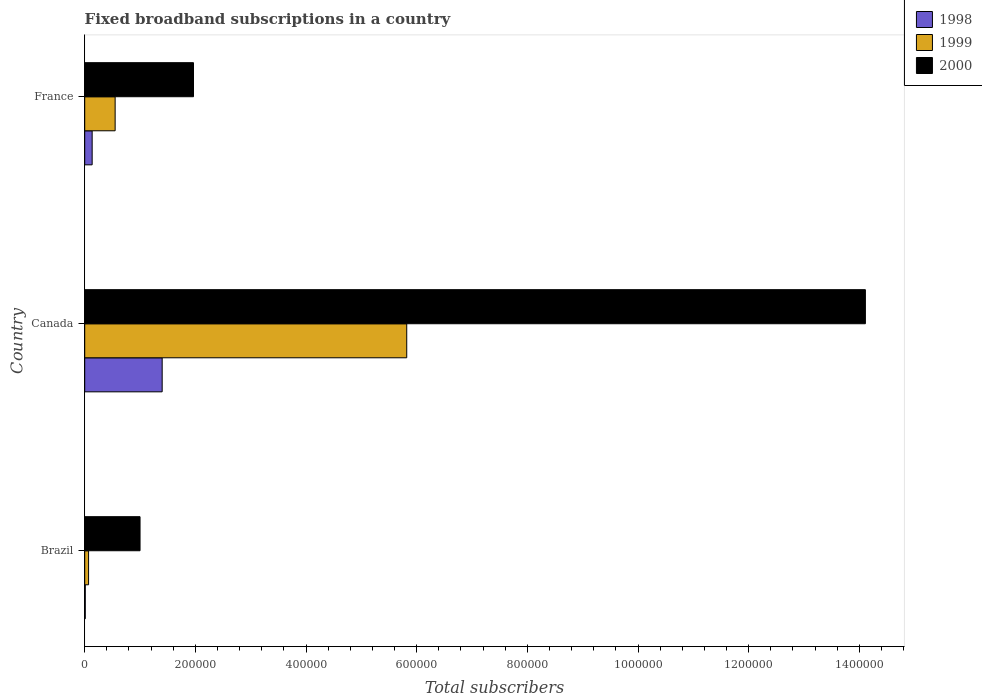How many groups of bars are there?
Offer a very short reply. 3. Are the number of bars on each tick of the Y-axis equal?
Offer a very short reply. Yes. How many bars are there on the 1st tick from the top?
Your response must be concise. 3. How many bars are there on the 2nd tick from the bottom?
Make the answer very short. 3. What is the number of broadband subscriptions in 1998 in France?
Make the answer very short. 1.35e+04. Across all countries, what is the maximum number of broadband subscriptions in 1999?
Provide a succinct answer. 5.82e+05. Across all countries, what is the minimum number of broadband subscriptions in 2000?
Provide a short and direct response. 1.00e+05. In which country was the number of broadband subscriptions in 2000 maximum?
Your answer should be compact. Canada. What is the total number of broadband subscriptions in 1999 in the graph?
Keep it short and to the point. 6.44e+05. What is the difference between the number of broadband subscriptions in 1998 in Brazil and that in Canada?
Your answer should be compact. -1.39e+05. What is the difference between the number of broadband subscriptions in 1999 in Brazil and the number of broadband subscriptions in 2000 in France?
Ensure brevity in your answer.  -1.90e+05. What is the average number of broadband subscriptions in 2000 per country?
Keep it short and to the point. 5.69e+05. What is the difference between the number of broadband subscriptions in 2000 and number of broadband subscriptions in 1998 in France?
Your answer should be compact. 1.83e+05. What is the ratio of the number of broadband subscriptions in 1998 in Brazil to that in Canada?
Provide a succinct answer. 0.01. Is the difference between the number of broadband subscriptions in 2000 in Brazil and France greater than the difference between the number of broadband subscriptions in 1998 in Brazil and France?
Make the answer very short. No. What is the difference between the highest and the second highest number of broadband subscriptions in 2000?
Your answer should be compact. 1.21e+06. What is the difference between the highest and the lowest number of broadband subscriptions in 1999?
Your answer should be very brief. 5.75e+05. In how many countries, is the number of broadband subscriptions in 1999 greater than the average number of broadband subscriptions in 1999 taken over all countries?
Offer a very short reply. 1. How many bars are there?
Keep it short and to the point. 9. Are all the bars in the graph horizontal?
Provide a short and direct response. Yes. How many countries are there in the graph?
Offer a terse response. 3. What is the difference between two consecutive major ticks on the X-axis?
Offer a terse response. 2.00e+05. Are the values on the major ticks of X-axis written in scientific E-notation?
Make the answer very short. No. Does the graph contain any zero values?
Keep it short and to the point. No. Where does the legend appear in the graph?
Your answer should be compact. Top right. How many legend labels are there?
Offer a very short reply. 3. What is the title of the graph?
Offer a terse response. Fixed broadband subscriptions in a country. Does "1967" appear as one of the legend labels in the graph?
Your answer should be compact. No. What is the label or title of the X-axis?
Offer a terse response. Total subscribers. What is the label or title of the Y-axis?
Your answer should be compact. Country. What is the Total subscribers in 1998 in Brazil?
Your response must be concise. 1000. What is the Total subscribers of 1999 in Brazil?
Provide a succinct answer. 7000. What is the Total subscribers of 2000 in Brazil?
Your answer should be very brief. 1.00e+05. What is the Total subscribers in 1998 in Canada?
Provide a short and direct response. 1.40e+05. What is the Total subscribers in 1999 in Canada?
Offer a terse response. 5.82e+05. What is the Total subscribers in 2000 in Canada?
Your answer should be very brief. 1.41e+06. What is the Total subscribers in 1998 in France?
Offer a terse response. 1.35e+04. What is the Total subscribers of 1999 in France?
Ensure brevity in your answer.  5.50e+04. What is the Total subscribers in 2000 in France?
Give a very brief answer. 1.97e+05. Across all countries, what is the maximum Total subscribers in 1999?
Your response must be concise. 5.82e+05. Across all countries, what is the maximum Total subscribers of 2000?
Your answer should be very brief. 1.41e+06. Across all countries, what is the minimum Total subscribers in 1999?
Provide a short and direct response. 7000. What is the total Total subscribers in 1998 in the graph?
Offer a very short reply. 1.54e+05. What is the total Total subscribers of 1999 in the graph?
Provide a short and direct response. 6.44e+05. What is the total Total subscribers in 2000 in the graph?
Offer a terse response. 1.71e+06. What is the difference between the Total subscribers of 1998 in Brazil and that in Canada?
Ensure brevity in your answer.  -1.39e+05. What is the difference between the Total subscribers of 1999 in Brazil and that in Canada?
Your response must be concise. -5.75e+05. What is the difference between the Total subscribers of 2000 in Brazil and that in Canada?
Provide a succinct answer. -1.31e+06. What is the difference between the Total subscribers of 1998 in Brazil and that in France?
Your response must be concise. -1.25e+04. What is the difference between the Total subscribers of 1999 in Brazil and that in France?
Give a very brief answer. -4.80e+04. What is the difference between the Total subscribers in 2000 in Brazil and that in France?
Provide a succinct answer. -9.66e+04. What is the difference between the Total subscribers in 1998 in Canada and that in France?
Provide a succinct answer. 1.27e+05. What is the difference between the Total subscribers in 1999 in Canada and that in France?
Your response must be concise. 5.27e+05. What is the difference between the Total subscribers in 2000 in Canada and that in France?
Offer a very short reply. 1.21e+06. What is the difference between the Total subscribers in 1998 in Brazil and the Total subscribers in 1999 in Canada?
Offer a terse response. -5.81e+05. What is the difference between the Total subscribers of 1998 in Brazil and the Total subscribers of 2000 in Canada?
Your answer should be compact. -1.41e+06. What is the difference between the Total subscribers of 1999 in Brazil and the Total subscribers of 2000 in Canada?
Provide a short and direct response. -1.40e+06. What is the difference between the Total subscribers in 1998 in Brazil and the Total subscribers in 1999 in France?
Keep it short and to the point. -5.40e+04. What is the difference between the Total subscribers of 1998 in Brazil and the Total subscribers of 2000 in France?
Give a very brief answer. -1.96e+05. What is the difference between the Total subscribers in 1999 in Brazil and the Total subscribers in 2000 in France?
Offer a very short reply. -1.90e+05. What is the difference between the Total subscribers of 1998 in Canada and the Total subscribers of 1999 in France?
Ensure brevity in your answer.  8.50e+04. What is the difference between the Total subscribers of 1998 in Canada and the Total subscribers of 2000 in France?
Provide a short and direct response. -5.66e+04. What is the difference between the Total subscribers in 1999 in Canada and the Total subscribers in 2000 in France?
Provide a succinct answer. 3.85e+05. What is the average Total subscribers of 1998 per country?
Give a very brief answer. 5.15e+04. What is the average Total subscribers in 1999 per country?
Keep it short and to the point. 2.15e+05. What is the average Total subscribers of 2000 per country?
Give a very brief answer. 5.69e+05. What is the difference between the Total subscribers in 1998 and Total subscribers in 1999 in Brazil?
Provide a succinct answer. -6000. What is the difference between the Total subscribers in 1998 and Total subscribers in 2000 in Brazil?
Offer a terse response. -9.90e+04. What is the difference between the Total subscribers of 1999 and Total subscribers of 2000 in Brazil?
Provide a short and direct response. -9.30e+04. What is the difference between the Total subscribers of 1998 and Total subscribers of 1999 in Canada?
Keep it short and to the point. -4.42e+05. What is the difference between the Total subscribers in 1998 and Total subscribers in 2000 in Canada?
Offer a very short reply. -1.27e+06. What is the difference between the Total subscribers of 1999 and Total subscribers of 2000 in Canada?
Keep it short and to the point. -8.29e+05. What is the difference between the Total subscribers of 1998 and Total subscribers of 1999 in France?
Make the answer very short. -4.15e+04. What is the difference between the Total subscribers in 1998 and Total subscribers in 2000 in France?
Your response must be concise. -1.83e+05. What is the difference between the Total subscribers of 1999 and Total subscribers of 2000 in France?
Your answer should be very brief. -1.42e+05. What is the ratio of the Total subscribers in 1998 in Brazil to that in Canada?
Your answer should be compact. 0.01. What is the ratio of the Total subscribers in 1999 in Brazil to that in Canada?
Provide a succinct answer. 0.01. What is the ratio of the Total subscribers in 2000 in Brazil to that in Canada?
Make the answer very short. 0.07. What is the ratio of the Total subscribers in 1998 in Brazil to that in France?
Your answer should be compact. 0.07. What is the ratio of the Total subscribers of 1999 in Brazil to that in France?
Keep it short and to the point. 0.13. What is the ratio of the Total subscribers in 2000 in Brazil to that in France?
Your answer should be compact. 0.51. What is the ratio of the Total subscribers in 1998 in Canada to that in France?
Offer a very short reply. 10.4. What is the ratio of the Total subscribers of 1999 in Canada to that in France?
Ensure brevity in your answer.  10.58. What is the ratio of the Total subscribers of 2000 in Canada to that in France?
Ensure brevity in your answer.  7.18. What is the difference between the highest and the second highest Total subscribers in 1998?
Offer a very short reply. 1.27e+05. What is the difference between the highest and the second highest Total subscribers in 1999?
Keep it short and to the point. 5.27e+05. What is the difference between the highest and the second highest Total subscribers of 2000?
Keep it short and to the point. 1.21e+06. What is the difference between the highest and the lowest Total subscribers in 1998?
Your response must be concise. 1.39e+05. What is the difference between the highest and the lowest Total subscribers of 1999?
Offer a very short reply. 5.75e+05. What is the difference between the highest and the lowest Total subscribers of 2000?
Offer a very short reply. 1.31e+06. 